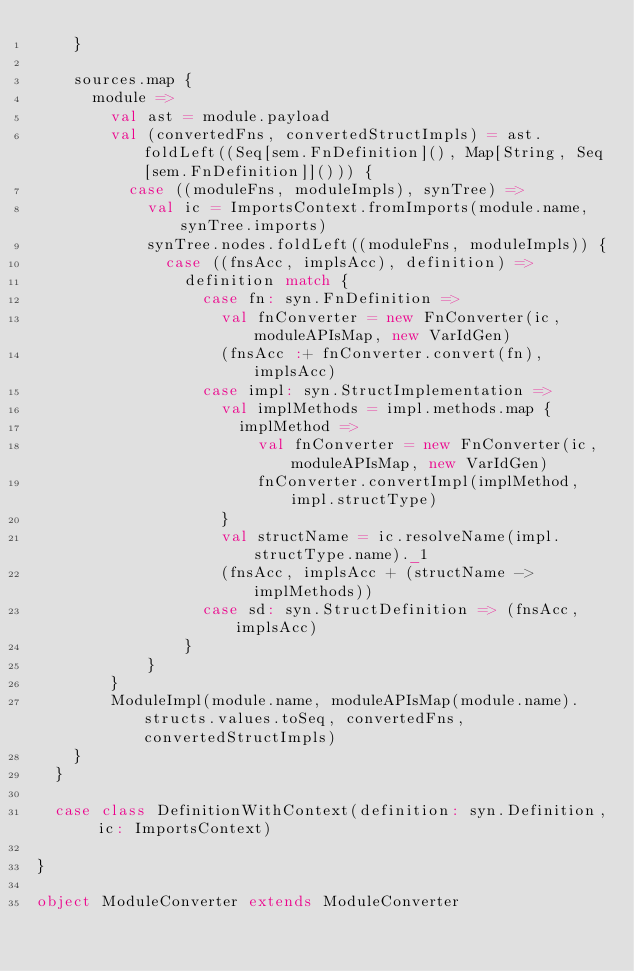Convert code to text. <code><loc_0><loc_0><loc_500><loc_500><_Scala_>    }

    sources.map {
      module =>
        val ast = module.payload
        val (convertedFns, convertedStructImpls) = ast.foldLeft((Seq[sem.FnDefinition](), Map[String, Seq[sem.FnDefinition]]())) {
          case ((moduleFns, moduleImpls), synTree) =>
            val ic = ImportsContext.fromImports(module.name, synTree.imports)
            synTree.nodes.foldLeft((moduleFns, moduleImpls)) {
              case ((fnsAcc, implsAcc), definition) =>
                definition match {
                  case fn: syn.FnDefinition =>
                    val fnConverter = new FnConverter(ic, moduleAPIsMap, new VarIdGen)
                    (fnsAcc :+ fnConverter.convert(fn), implsAcc)
                  case impl: syn.StructImplementation =>
                    val implMethods = impl.methods.map {
                      implMethod =>
                        val fnConverter = new FnConverter(ic, moduleAPIsMap, new VarIdGen)
                        fnConverter.convertImpl(implMethod, impl.structType)
                    }
                    val structName = ic.resolveName(impl.structType.name)._1
                    (fnsAcc, implsAcc + (structName -> implMethods))
                  case sd: syn.StructDefinition => (fnsAcc, implsAcc)
                }
            }
        }
        ModuleImpl(module.name, moduleAPIsMap(module.name).structs.values.toSeq, convertedFns, convertedStructImpls)
    }
  }

  case class DefinitionWithContext(definition: syn.Definition, ic: ImportsContext)

}

object ModuleConverter extends ModuleConverter</code> 